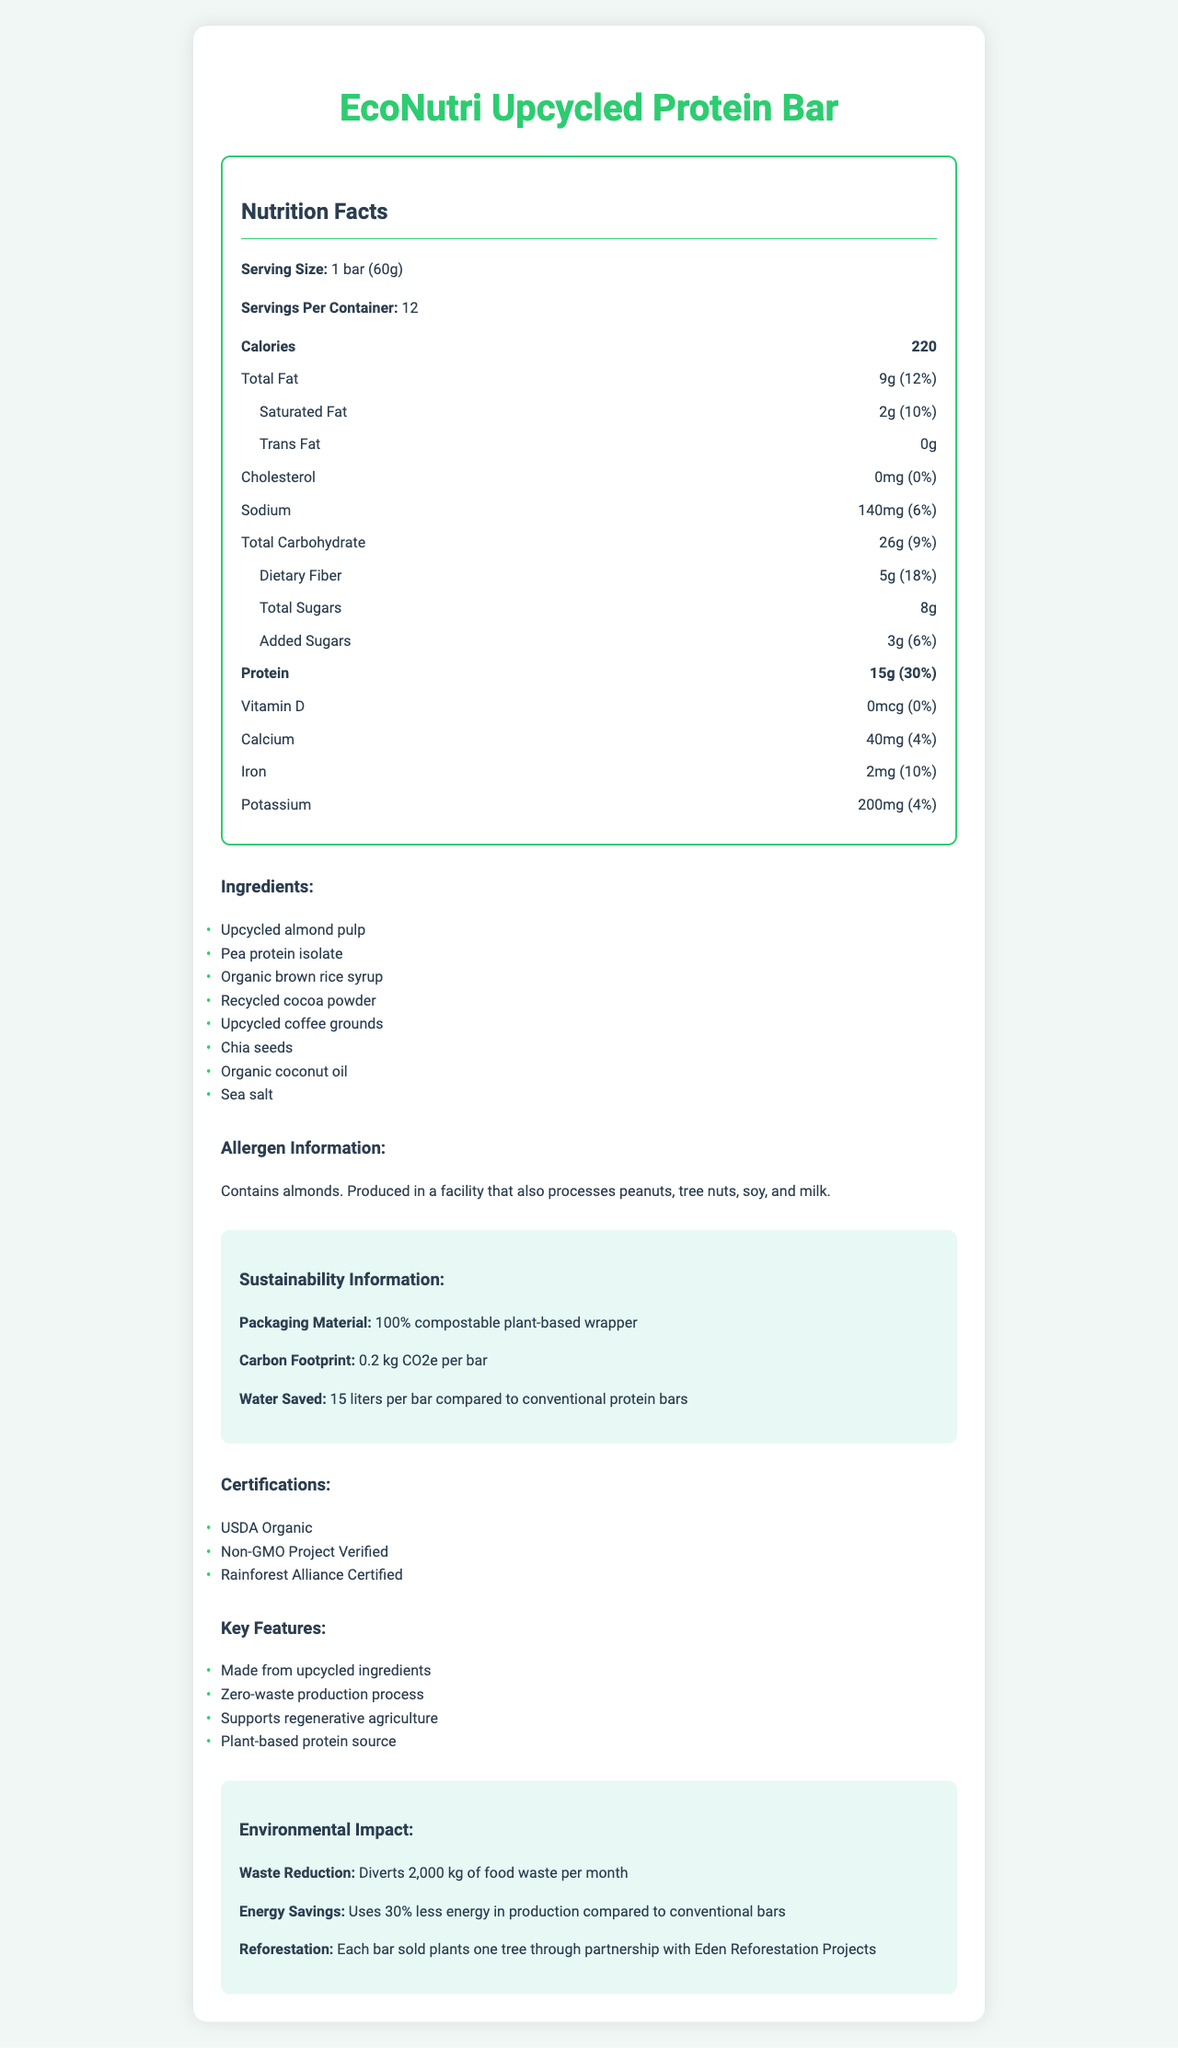what is the serving size per bar? The serving size per bar is clearly mentioned as "1 bar (60g)" in the document.
Answer: 1 bar (60g) how many calories are in each serving? The document states that each serving size contains 220 calories.
Answer: 220 what is the total fat content per serving? The total fat content per serving is indicated as 9g in the document.
Answer: 9g how much protein does one serving provide? The document specifies that one serving provides 15g of protein.
Answer: 15g what allergens are present in the EcoNutri Upcycled Protein Bar? The allergen information section of the document states the presence of almonds and mentions that the bars are produced in a facility with peanuts, tree nuts, soy, and milk.
Answer: Contains almonds. Produced in a facility that also processes peanuts, tree nuts, soy, and milk. what is the percentage of daily value for saturated fat in one serving? The document shows that the daily value percentage for saturated fat is 10%.
Answer: 10% how much dietary fiber is in one bar? The dietary fiber content per serving is listed as 5g.
Answer: 5g what is the amount of calcium found in each bar, and its daily value percentage? Each bar contains 40mg of calcium, which is 4% of the daily value.
Answer: 40mg, 4% what type of certification does the product have? (select all that apply) A. USDA Organic B. Fair Trade Certified C. Non-GMO Project Verified D. Rainforest Alliance Certified The product has certifications for USDA Organic, Non-GMO Project Verified, and Rainforest Alliance Certified.
Answer: A, C, D how much water is saved per bar compared to conventional protein bars? A. 10 liters B. 15 liters C. 20 liters D. 25 liters The sustainability information mentions that each bar saves 15 liters of water compared to conventional protein bars.
Answer: B. 15 liters is the product packaging compostable? The document states that the packaging material is a "100% compostable plant-based wrapper."
Answer: Yes does the product contain vitamin D? The vitamin D amount is listed as 0mcg with 0% daily value, indicating no vitamin D is present.
Answer: No describe the main idea of the document. The document aims to give a detailed overview of the nutritional profile and sustainability features of the EcoNutri Upcycled Protein Bar, emphasizing its eco-friendly manufacturing process and benefits.
Answer: The document provides comprehensive nutritional information for the EcoNutri Upcycled Protein Bar, including serving size, calories, macronutrients, vitamins, and minerals. It also highlights the list of ingredients, allergen information, sustainability aspects like packaging and carbon footprint, certifications, marketing claims, and environmental impact measures. how many grams of trans fat are in each serving? The document clearly states that each serving contains 0g of trans fat.
Answer: 0g what are the marketing claims for the product? The marketing claims section lists these four key features of the product.
Answer: Made from upcycled ingredients, Zero-waste production process, Supports regenerative agriculture, Plant-based protein source how many servings are there per container? The document notes that there are 12 servings per container.
Answer: 12 how many kilograms of food waste does the product divert per month? The environmental impact section specifies that the product diverts 2,000 kg of food waste per month.
Answer: 2,000 kg are the upcycled ingredients used in the product listed? The document does not specify which ingredients are upcycled. It lists the ingredients but does not indicate which ones are upcycled.
Answer: No is the product suitable for a vegan diet? The document does not explicitly state whether the product is vegan. The ingredients appear plant-based, but verification is needed.
Answer: Not enough information 